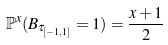Convert formula to latex. <formula><loc_0><loc_0><loc_500><loc_500>\mathbb { P } ^ { x } ( B _ { \tau _ { [ - 1 , 1 ] } } = 1 ) = \frac { x + 1 } { 2 }</formula> 